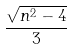Convert formula to latex. <formula><loc_0><loc_0><loc_500><loc_500>\frac { \sqrt { n ^ { 2 } - 4 } } { 3 }</formula> 